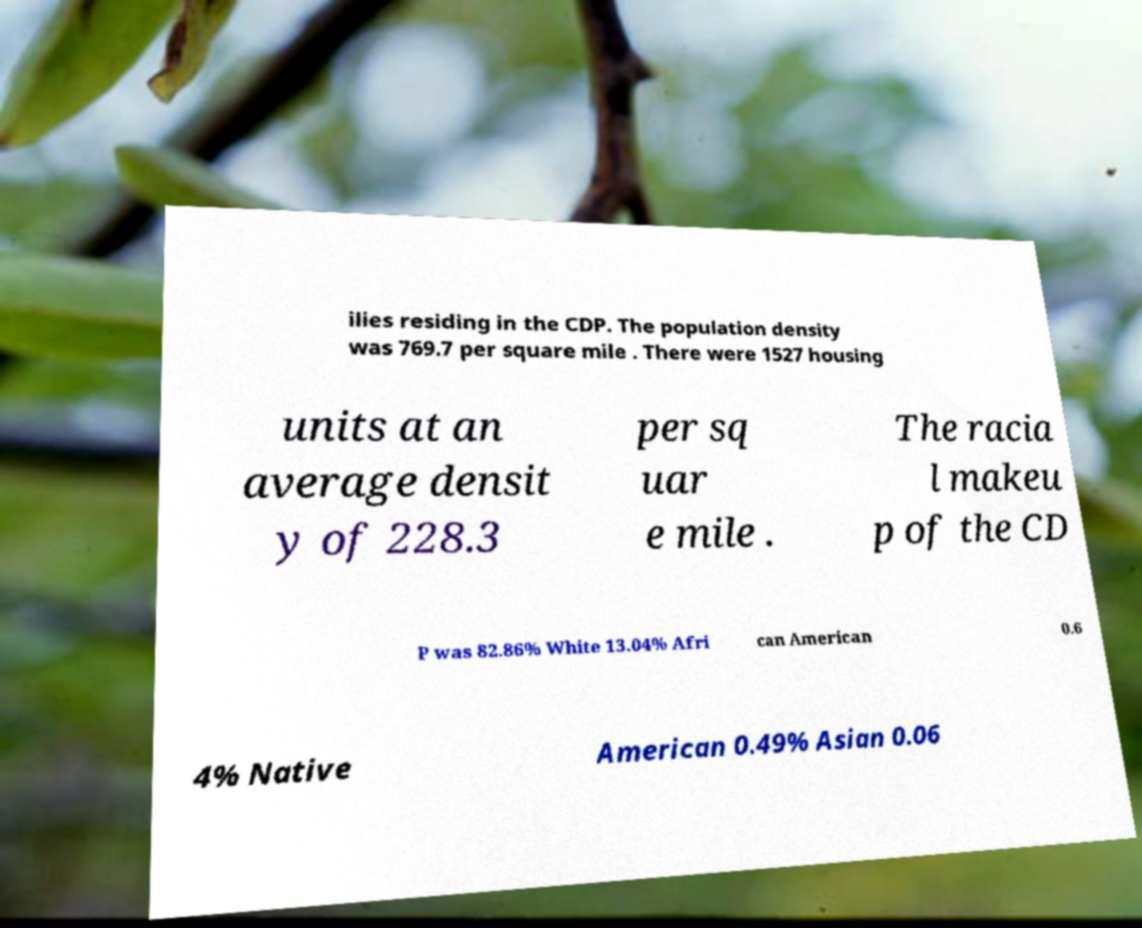For documentation purposes, I need the text within this image transcribed. Could you provide that? ilies residing in the CDP. The population density was 769.7 per square mile . There were 1527 housing units at an average densit y of 228.3 per sq uar e mile . The racia l makeu p of the CD P was 82.86% White 13.04% Afri can American 0.6 4% Native American 0.49% Asian 0.06 